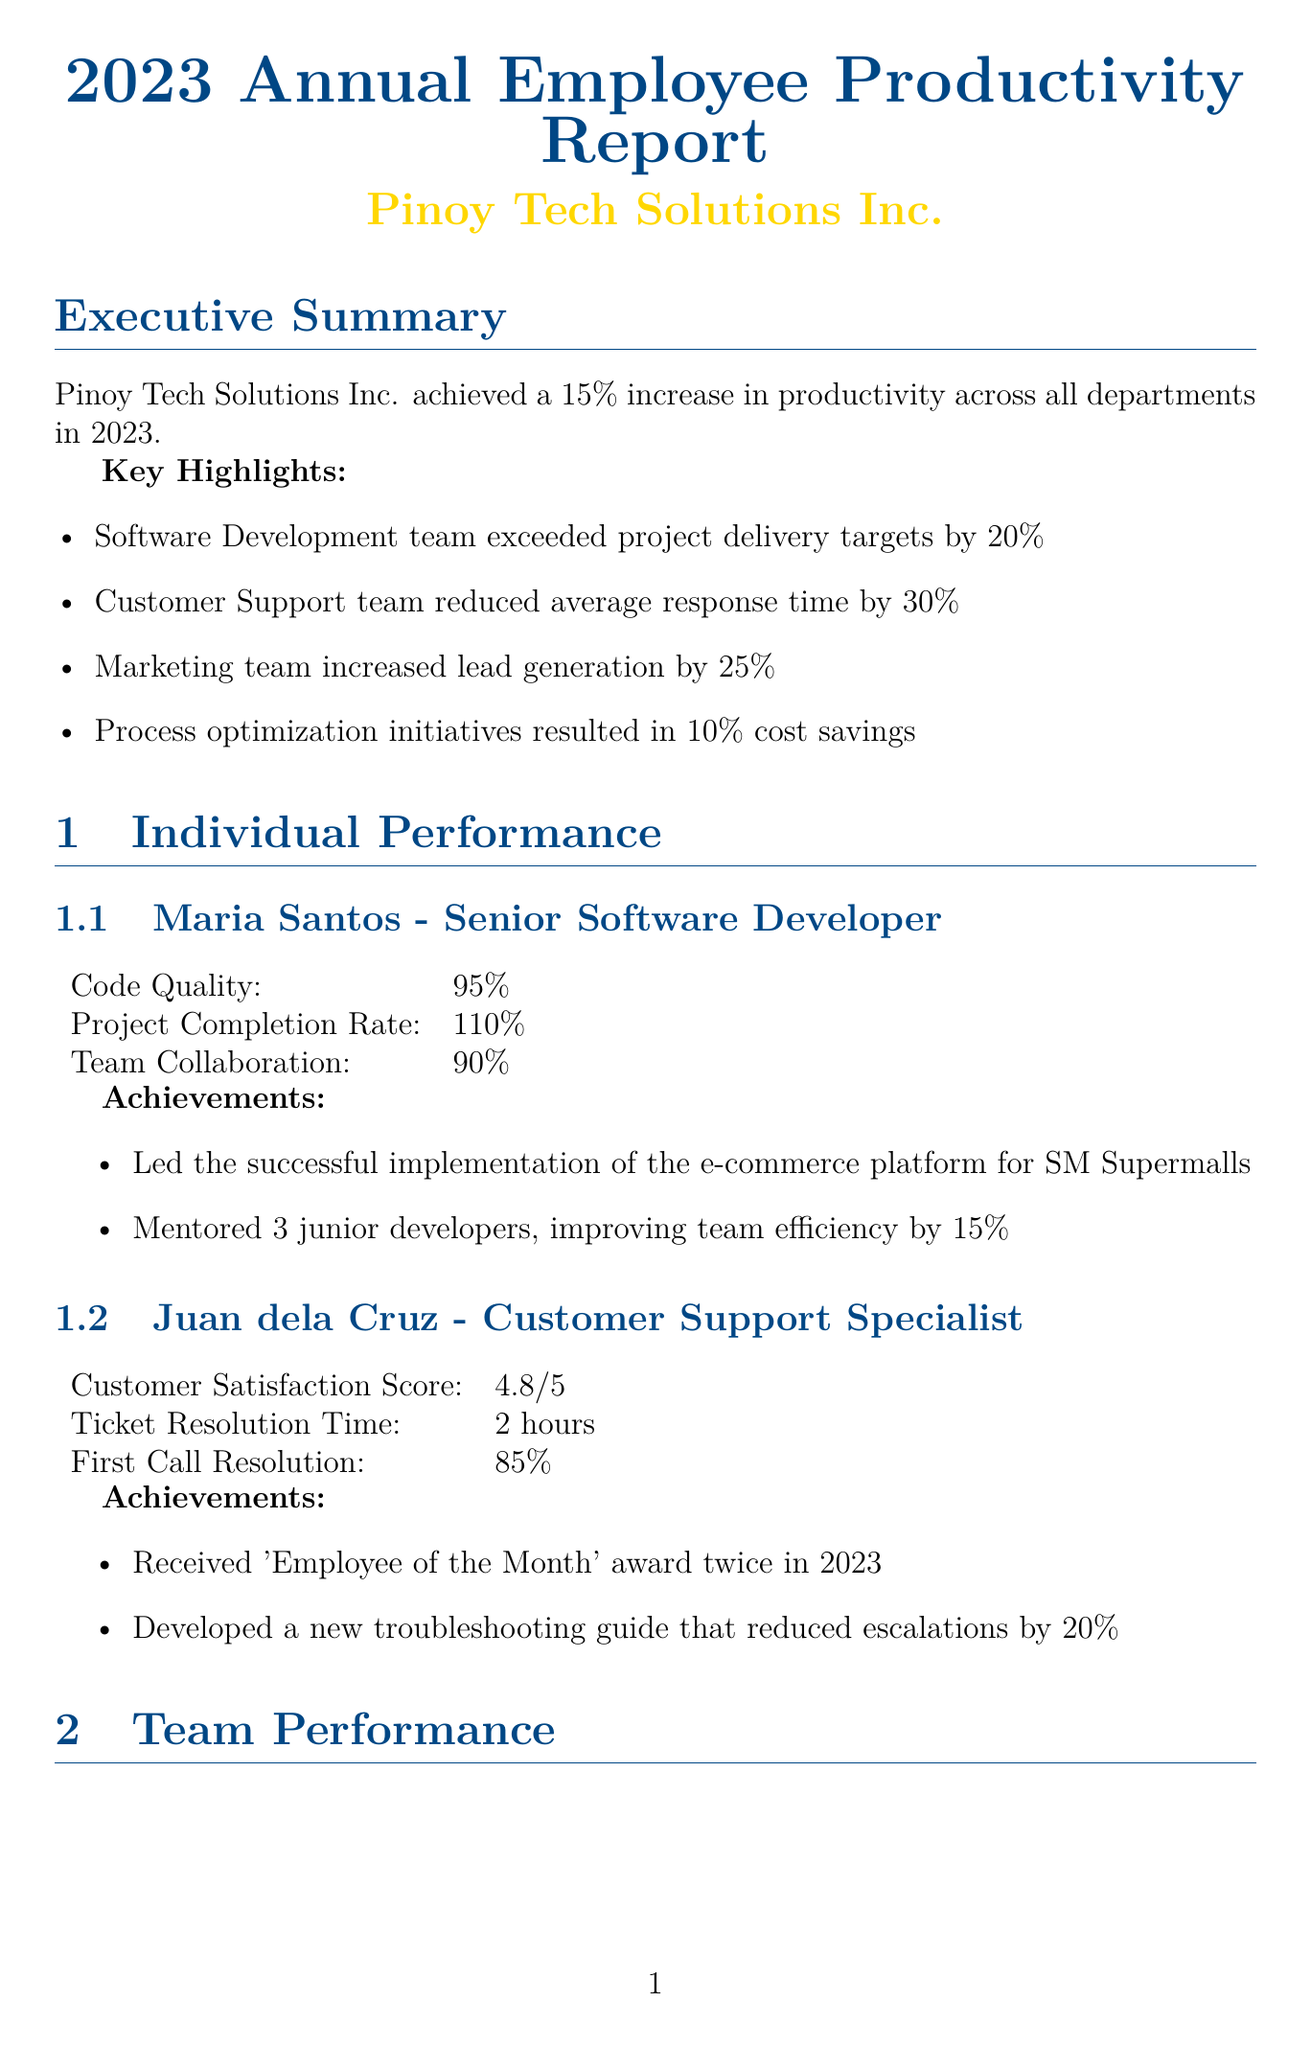What was the percentage increase in productivity for 2023? The overall productivity increase for Pinoy Tech Solutions Inc. was 15% across all departments in 2023.
Answer: 15% What achievement did Maria Santos receive regarding team mentoring? Maria Santos mentored 3 junior developers, which improved team efficiency by 15%.
Answer: Improved team efficiency by 15% How much did the Customer Support team reduce average response time? The Customer Support team reduced average response time by 30% throughout the year.
Answer: 30% What was Juan dela Cruz's customer satisfaction score? Juan dela Cruz achieved a customer satisfaction score of 4.8 out of 5.
Answer: 4.8/5 What is one recommendation for process optimization? The report suggests implementing a unified project management tool across all departments as a process optimization recommendation.
Answer: Unified project management tool What was the project delivery rate for the Software Development team? The Software Development team had a project delivery rate of 120%.
Answer: 120% What top skill was acquired related to machine learning? The top skill acquired in relation to machine learning is Artificial Intelligence and Machine Learning.
Answer: Artificial Intelligence and Machine Learning Which team generated 125 leads as part of their performance? The Marketing team achieved a lead generation rate of 125%.
Answer: Marketing What significant improvement did the automated code review process achieve? The automated code review process reduced code review time by 40% and improved code quality by 25%.
Answer: Reduced code review time by 40% 